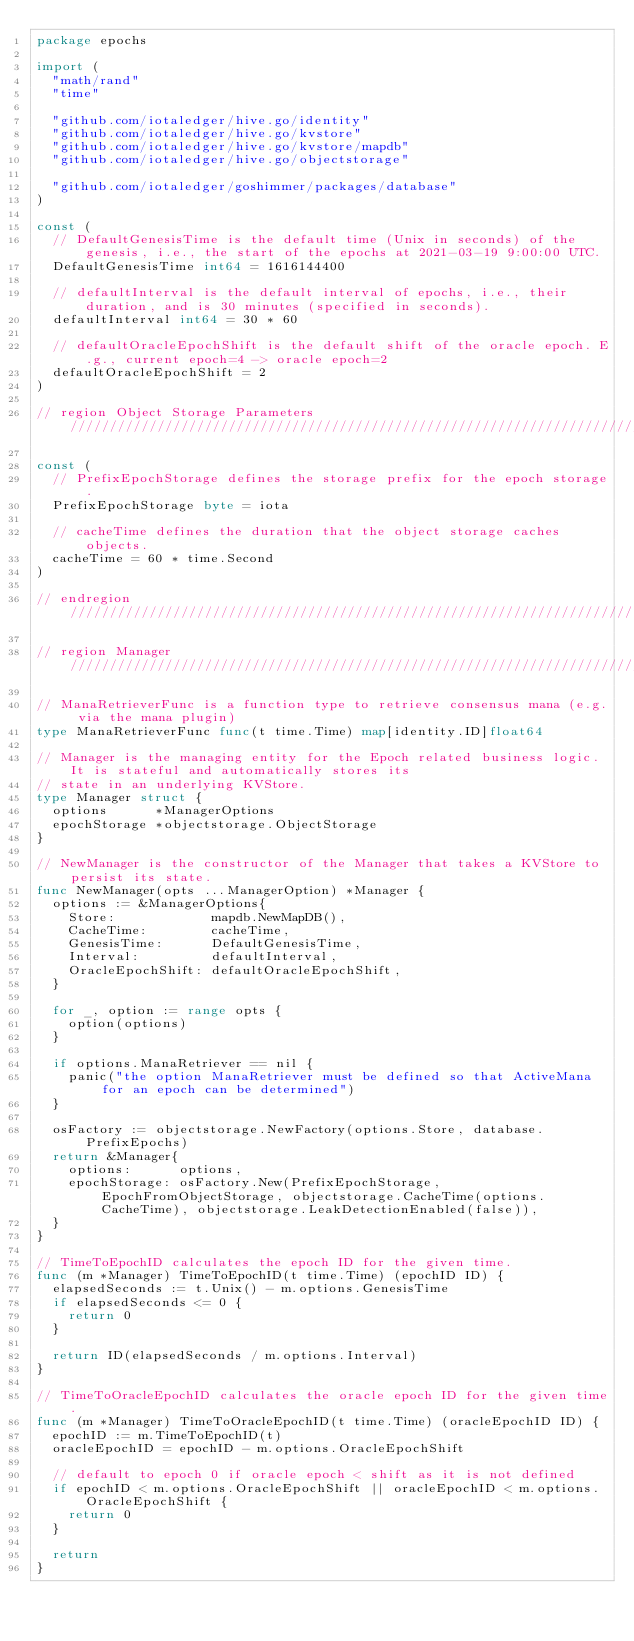<code> <loc_0><loc_0><loc_500><loc_500><_Go_>package epochs

import (
	"math/rand"
	"time"

	"github.com/iotaledger/hive.go/identity"
	"github.com/iotaledger/hive.go/kvstore"
	"github.com/iotaledger/hive.go/kvstore/mapdb"
	"github.com/iotaledger/hive.go/objectstorage"

	"github.com/iotaledger/goshimmer/packages/database"
)

const (
	// DefaultGenesisTime is the default time (Unix in seconds) of the genesis, i.e., the start of the epochs at 2021-03-19 9:00:00 UTC.
	DefaultGenesisTime int64 = 1616144400

	// defaultInterval is the default interval of epochs, i.e., their duration, and is 30 minutes (specified in seconds).
	defaultInterval int64 = 30 * 60

	// defaultOracleEpochShift is the default shift of the oracle epoch. E.g., current epoch=4 -> oracle epoch=2
	defaultOracleEpochShift = 2
)

// region Object Storage Parameters ////////////////////////////////////////////////////////////////////////////////////

const (
	// PrefixEpochStorage defines the storage prefix for the epoch storage.
	PrefixEpochStorage byte = iota

	// cacheTime defines the duration that the object storage caches objects.
	cacheTime = 60 * time.Second
)

// endregion ///////////////////////////////////////////////////////////////////////////////////////////////////////////

// region Manager //////////////////////////////////////////////////////////////////////////////////////////////////////

// ManaRetrieverFunc is a function type to retrieve consensus mana (e.g. via the mana plugin)
type ManaRetrieverFunc func(t time.Time) map[identity.ID]float64

// Manager is the managing entity for the Epoch related business logic. It is stateful and automatically stores its
// state in an underlying KVStore.
type Manager struct {
	options      *ManagerOptions
	epochStorage *objectstorage.ObjectStorage
}

// NewManager is the constructor of the Manager that takes a KVStore to persist its state.
func NewManager(opts ...ManagerOption) *Manager {
	options := &ManagerOptions{
		Store:            mapdb.NewMapDB(),
		CacheTime:        cacheTime,
		GenesisTime:      DefaultGenesisTime,
		Interval:         defaultInterval,
		OracleEpochShift: defaultOracleEpochShift,
	}

	for _, option := range opts {
		option(options)
	}

	if options.ManaRetriever == nil {
		panic("the option ManaRetriever must be defined so that ActiveMana for an epoch can be determined")
	}

	osFactory := objectstorage.NewFactory(options.Store, database.PrefixEpochs)
	return &Manager{
		options:      options,
		epochStorage: osFactory.New(PrefixEpochStorage, EpochFromObjectStorage, objectstorage.CacheTime(options.CacheTime), objectstorage.LeakDetectionEnabled(false)),
	}
}

// TimeToEpochID calculates the epoch ID for the given time.
func (m *Manager) TimeToEpochID(t time.Time) (epochID ID) {
	elapsedSeconds := t.Unix() - m.options.GenesisTime
	if elapsedSeconds <= 0 {
		return 0
	}

	return ID(elapsedSeconds / m.options.Interval)
}

// TimeToOracleEpochID calculates the oracle epoch ID for the given time.
func (m *Manager) TimeToOracleEpochID(t time.Time) (oracleEpochID ID) {
	epochID := m.TimeToEpochID(t)
	oracleEpochID = epochID - m.options.OracleEpochShift

	// default to epoch 0 if oracle epoch < shift as it is not defined
	if epochID < m.options.OracleEpochShift || oracleEpochID < m.options.OracleEpochShift {
		return 0
	}

	return
}
</code> 